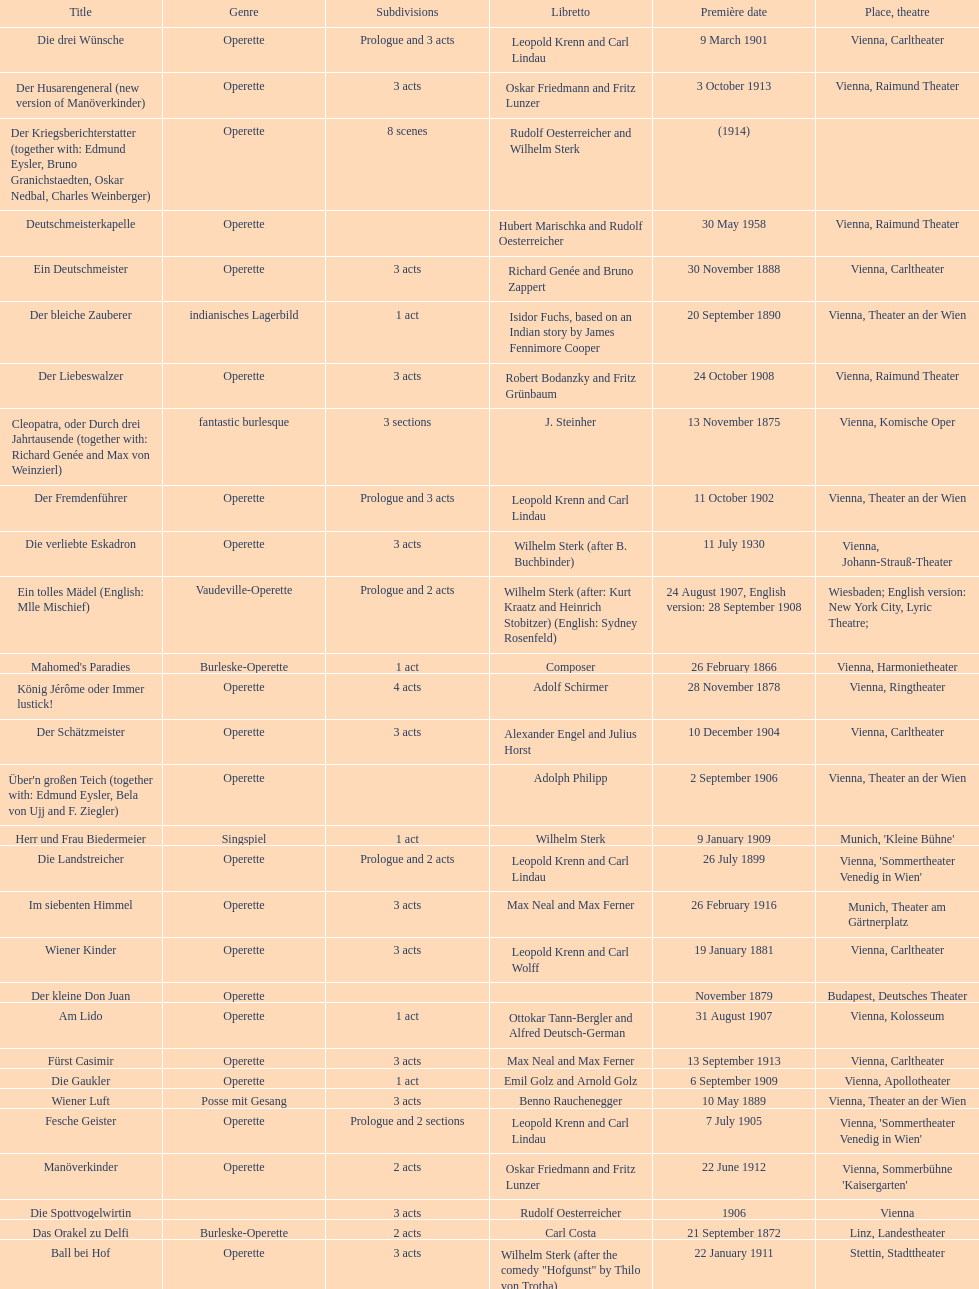Which genre is featured the most in this chart? Operette. 